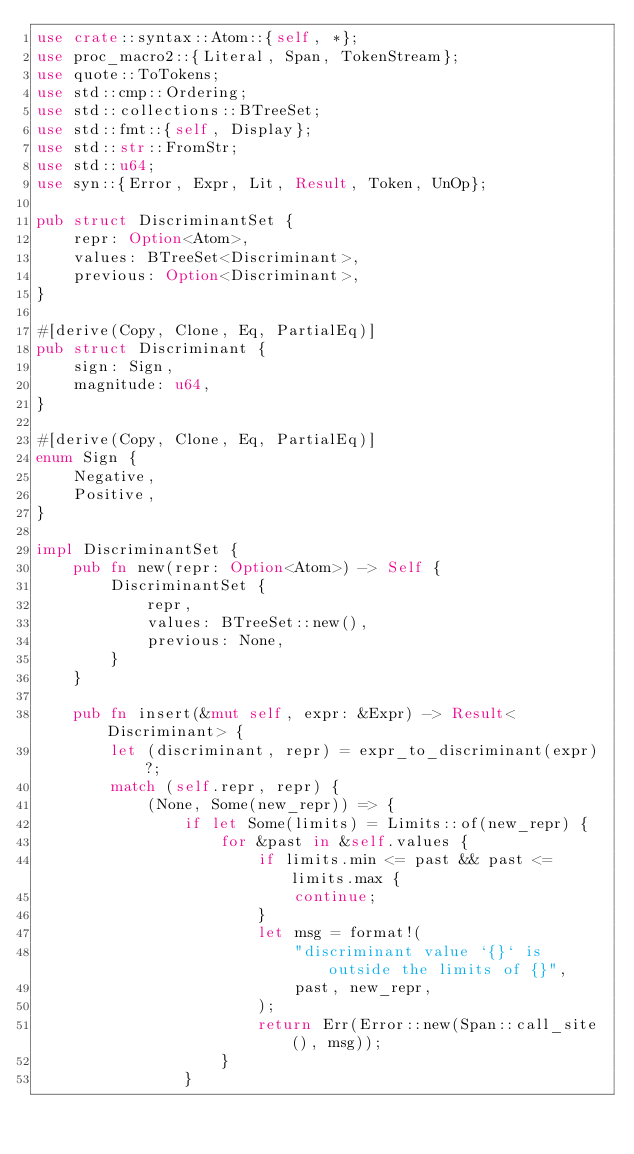<code> <loc_0><loc_0><loc_500><loc_500><_Rust_>use crate::syntax::Atom::{self, *};
use proc_macro2::{Literal, Span, TokenStream};
use quote::ToTokens;
use std::cmp::Ordering;
use std::collections::BTreeSet;
use std::fmt::{self, Display};
use std::str::FromStr;
use std::u64;
use syn::{Error, Expr, Lit, Result, Token, UnOp};

pub struct DiscriminantSet {
    repr: Option<Atom>,
    values: BTreeSet<Discriminant>,
    previous: Option<Discriminant>,
}

#[derive(Copy, Clone, Eq, PartialEq)]
pub struct Discriminant {
    sign: Sign,
    magnitude: u64,
}

#[derive(Copy, Clone, Eq, PartialEq)]
enum Sign {
    Negative,
    Positive,
}

impl DiscriminantSet {
    pub fn new(repr: Option<Atom>) -> Self {
        DiscriminantSet {
            repr,
            values: BTreeSet::new(),
            previous: None,
        }
    }

    pub fn insert(&mut self, expr: &Expr) -> Result<Discriminant> {
        let (discriminant, repr) = expr_to_discriminant(expr)?;
        match (self.repr, repr) {
            (None, Some(new_repr)) => {
                if let Some(limits) = Limits::of(new_repr) {
                    for &past in &self.values {
                        if limits.min <= past && past <= limits.max {
                            continue;
                        }
                        let msg = format!(
                            "discriminant value `{}` is outside the limits of {}",
                            past, new_repr,
                        );
                        return Err(Error::new(Span::call_site(), msg));
                    }
                }</code> 